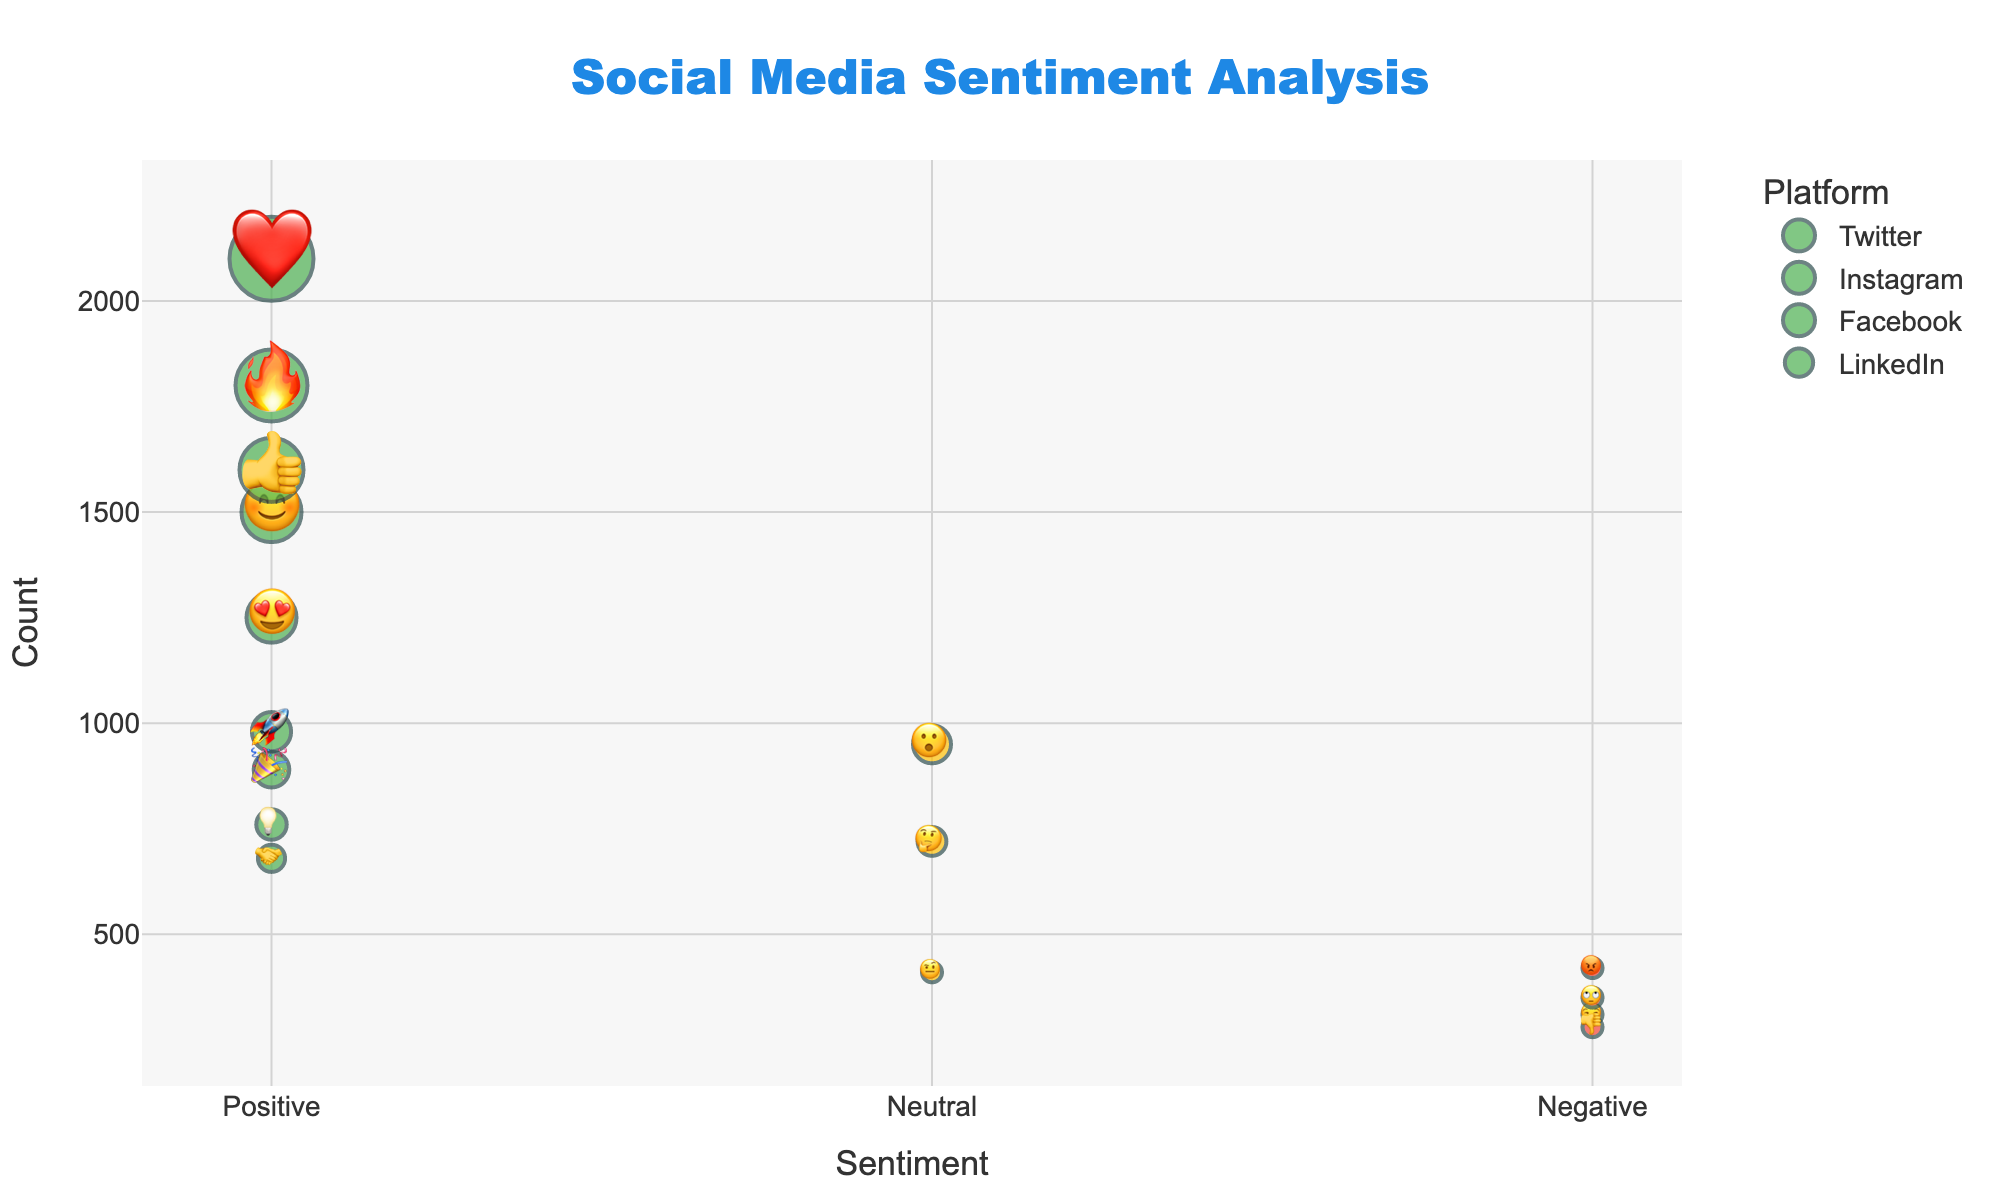what is the sentiment with the highest count on Instagram? On Instagram, the highest count sentiment is represented by the emoji with the largest count value. According to the data, the ❤️ emoji has a count of 2100, which is the highest.
Answer: Positive (❤️) What is the total number of negative sentiments across all platforms? To find the total number of negative sentiments, sum the counts for each negative sentiment (😒, 👎, 😡, 🙄). Summing them: 310 (Twitter) + 280 (Instagram) + 420 (Facebook) + 350 (Facebook) = 1360.
Answer: 1360 Which platform has the highest number of positive sentiment counts? Out of the platforms, Instagram has the highest counts for positive sentiments when adding all the positive counts (❤️,🔥,😊): 2100 + 1800 + 1500 = 5400.
Answer: Instagram How many more positive sentiments does Twitter have compared to LinkedIn? To find the difference, sum the positive sentiments for both platforms and subtract the smaller sum from the larger sum. Twitter: 1250 (😍) + 980 (🚀) = 2230, LinkedIn: 890 (🎉) + 760 (💡) + 680 (🤝) = 2330. Difference: 2330 - 2230 = 100.
Answer: 100 more for LinkedIn Which sentiment has the lowest count on Facebook and how many counts does it have? The sentiment with the lowest count on Facebook is denoted by the least number of counts within the platform's sentiments in the data. The emojis are 👍 (1600), 😮 (950), 😡 (420), and 🙄 (350). The lowest count is for 🙄 with 350.
Answer: 🙄 with 350 What is the combined count of neutral sentiments from all platforms? To get the combined neutral sentiments, sum the counts wherever the sentiment is neutral. Count (neutral): 🤔 (Twitter) = 720, 😮 (Facebook) = 950, 🤨 (LinkedIn) = 410. Total = 720 + 950 + 410 = 2080.
Answer: 2080 Is the neutral sentiment on Facebook higher than the neutral sentiment on LinkedIn? Compare the counts for neutral sentiments on both platforms. Facebook's neutral sentiment (😮) has a count of 950, and LinkedIn's neutral sentiment (🤨) has a count of 410. Since 950 > 410, Facebook's neutral sentiment is higher.
Answer: Yes Which sentiment platform-emoji pair has the lowest count and how much is it? Look for the smallest count number in the entire dataset. The available data has counts as 310, 280, 420, 350, etc. The smallest number is 280 for the Instagram negative sentiment (👎).
Answer: 👎 (Instagram) with 280 